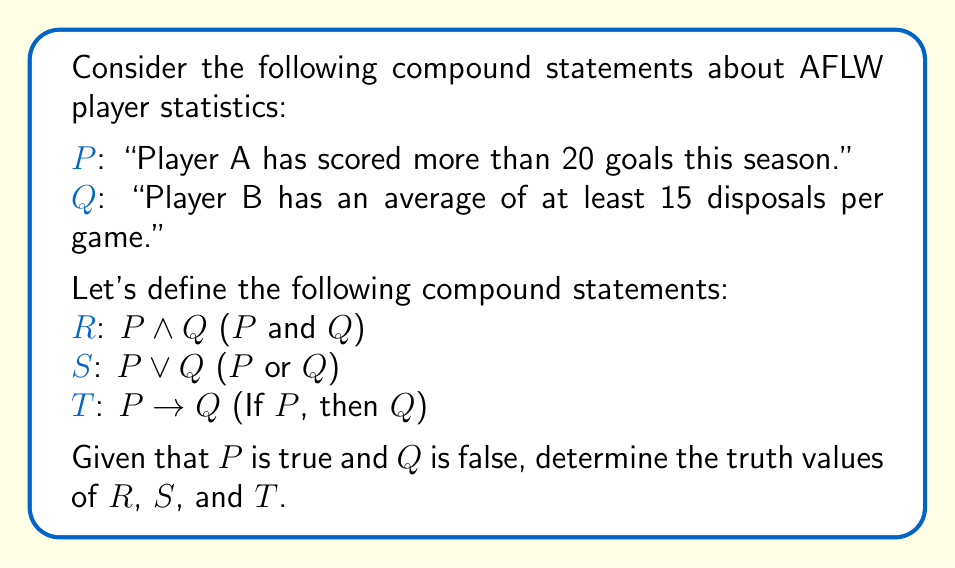Provide a solution to this math problem. To solve this problem, we need to analyze each compound statement based on the given truth values of P and Q. Let's break it down step-by-step:

1. Given:
   P is true (T)
   Q is false (F)

2. Analyze R: P ∧ Q (P and Q)
   The conjunction (∧) is true only when both statements are true.
   P ∧ Q = T ∧ F = F
   Therefore, R is false.

3. Analyze S: P ∨ Q (P or Q)
   The disjunction (∨) is true when at least one statement is true.
   P ∨ Q = T ∨ F = T
   Therefore, S is true.

4. Analyze T: P → Q (If P, then Q)
   The implication (→) is false only when the antecedent (P) is true and the consequent (Q) is false.
   P → Q = T → F = F
   Therefore, T is false.

We can summarize these results in a truth table:

$$
\begin{array}{|c|c|c|c|c|}
\hline
P & Q & R: P \land Q & S: P \lor Q & T: P \rightarrow Q \\
\hline
T & F & F & T & F \\
\hline
\end{array}
$$

This analysis allows an AFLW coach to understand the logical relationships between player statistics and how they can be combined to form more complex statements about team performance.
Answer: R (P ∧ Q) is false, S (P ∨ Q) is true, and T (P → Q) is false. 